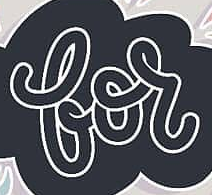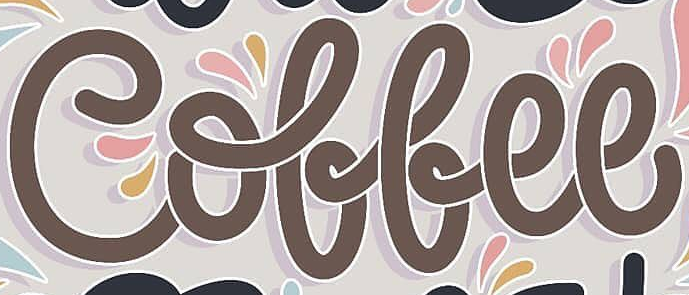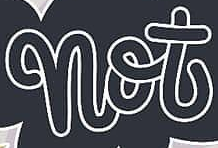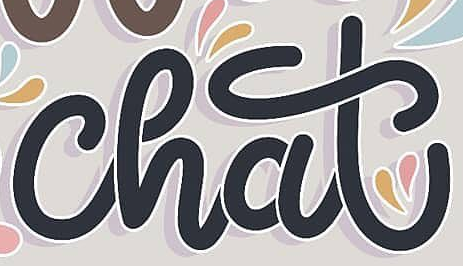Read the text from these images in sequence, separated by a semicolon. for; Coffee; not; chat 